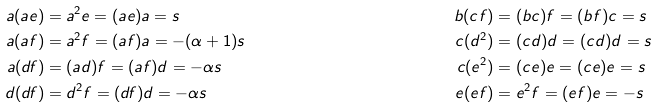Convert formula to latex. <formula><loc_0><loc_0><loc_500><loc_500>a ( a e ) & = a ^ { 2 } e = ( a e ) a = s & b ( c f ) & = ( b c ) f = ( b f ) c = s \\ a ( a f ) & = a ^ { 2 } f = ( a f ) a = - ( \alpha + 1 ) s & c ( d ^ { 2 } ) & = ( c d ) d = ( c d ) d = s \\ a ( d f ) & = ( a d ) f = ( a f ) d = - \alpha s & c ( e ^ { 2 } ) & = ( c e ) e = ( c e ) e = s \\ d ( d f ) & = d ^ { 2 } f = ( d f ) d = - \alpha s & e ( e f ) & = e ^ { 2 } f = ( e f ) e = - s</formula> 